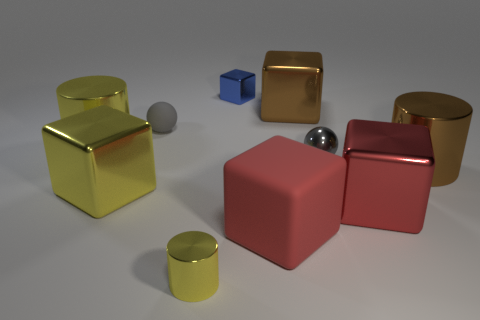What is the color of the big shiny thing that is in front of the big block that is left of the small yellow object that is in front of the blue metal object?
Provide a short and direct response. Red. There is a small object that is left of the tiny cylinder; is its color the same as the small sphere in front of the big yellow shiny cylinder?
Your answer should be compact. Yes. Are there any other things that have the same color as the small shiny cube?
Offer a terse response. No. Are there fewer large metal cubes that are to the left of the big yellow metallic cylinder than large red rubber things?
Keep it short and to the point. Yes. What number of yellow metal cylinders are there?
Your answer should be very brief. 2. Does the big red metal object have the same shape as the rubber thing that is right of the small yellow object?
Offer a terse response. Yes. Is the number of brown shiny things that are on the left side of the rubber sphere less than the number of tiny gray matte balls that are on the left side of the tiny shiny ball?
Ensure brevity in your answer.  Yes. Is the gray rubber thing the same shape as the blue metal thing?
Keep it short and to the point. No. How big is the gray rubber sphere?
Give a very brief answer. Small. What color is the small metallic thing that is on the left side of the metallic sphere and behind the red metal thing?
Your answer should be compact. Blue. 